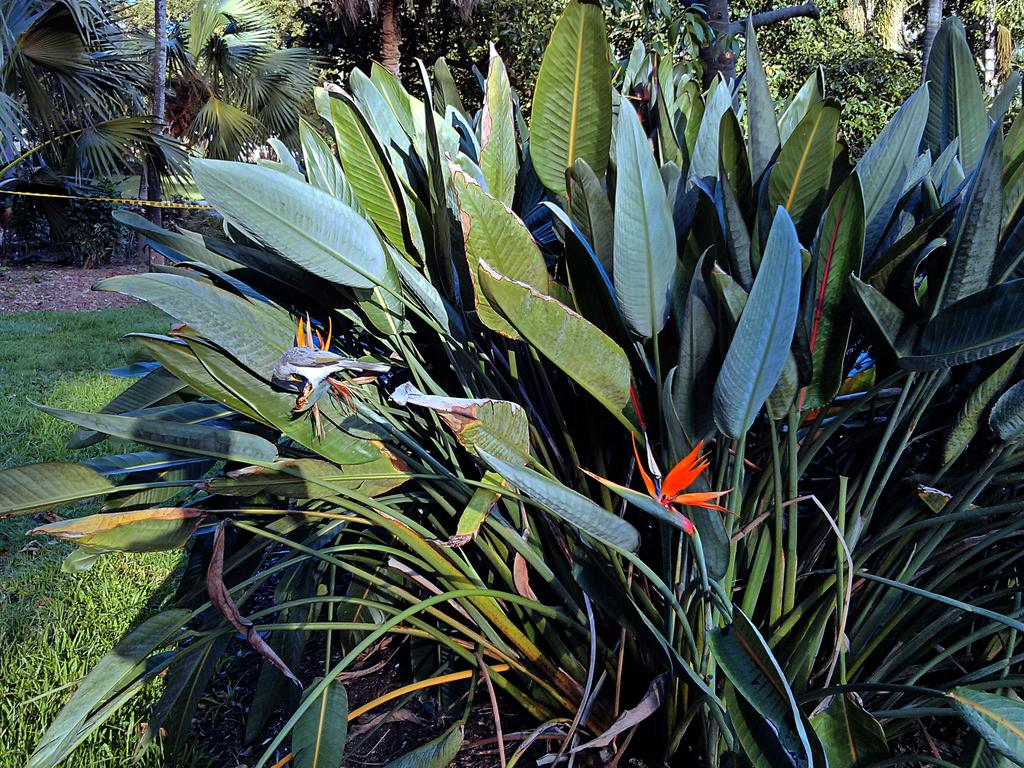What type of vegetation can be seen in the image? There are plants, grass, and trees in the image. What time of day was the image taken? The image was taken during the day. What is the rhythm of the plants in the image? There is no rhythm associated with the plants in the image, as they are stationary and not engaged in any activity that could be described as having a rhythm. 